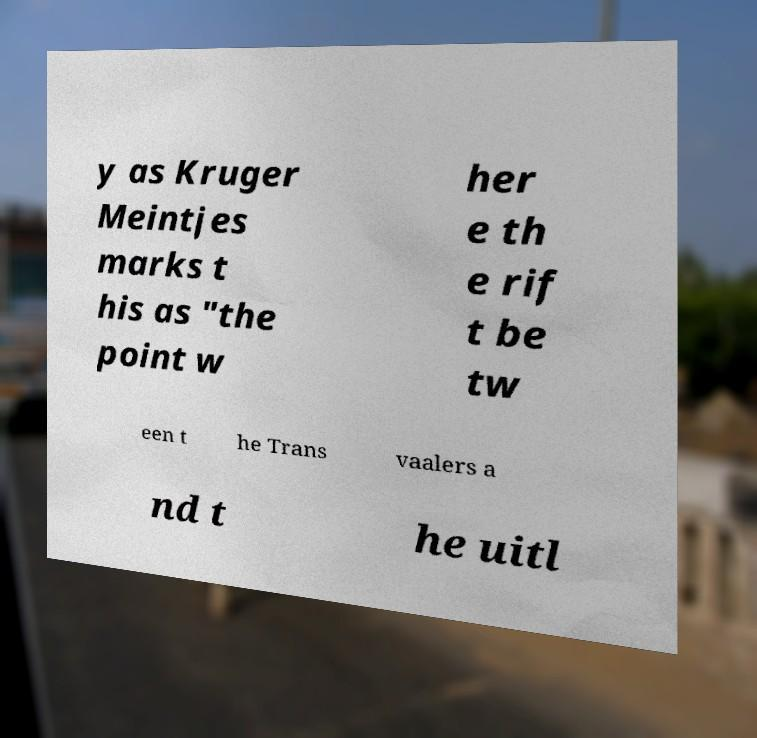Can you read and provide the text displayed in the image?This photo seems to have some interesting text. Can you extract and type it out for me? y as Kruger Meintjes marks t his as "the point w her e th e rif t be tw een t he Trans vaalers a nd t he uitl 